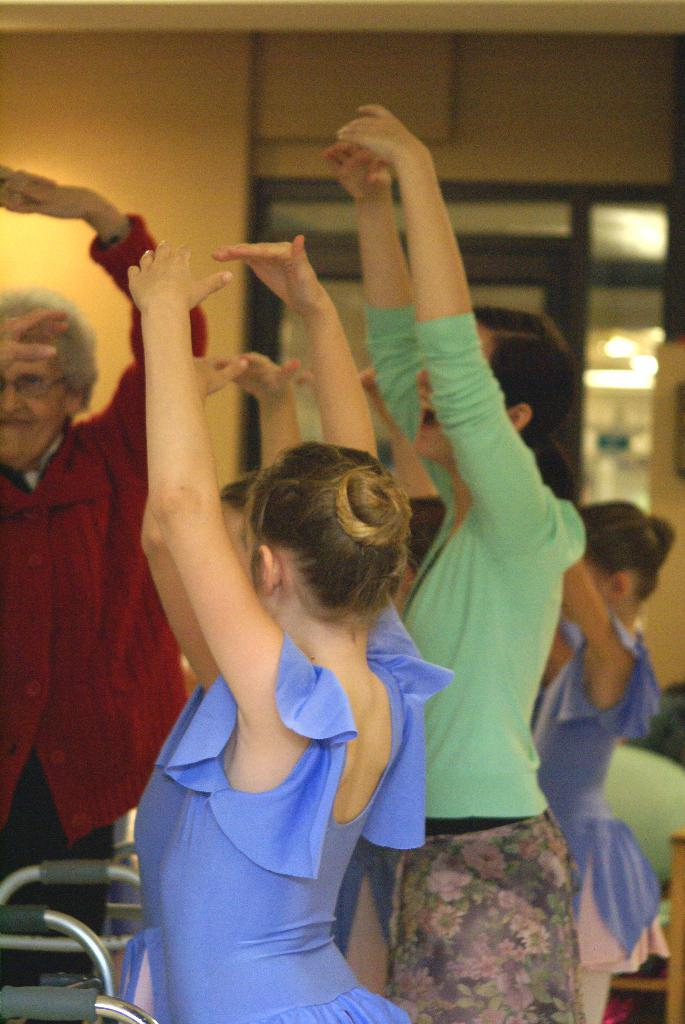Who or what is present in the image? There are people in the image. What are the people doing with their hands? The people have raised their hands. How do the people appear to be feeling? The people appear to be smiling. What type of throne is visible in the image? There is no throne present in the image. What does the company logo look like in the image? There is no company logo or reference to a company in the image. 